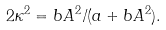<formula> <loc_0><loc_0><loc_500><loc_500>2 \kappa ^ { 2 } = b A ^ { 2 } / ( a + b A ^ { 2 } ) .</formula> 